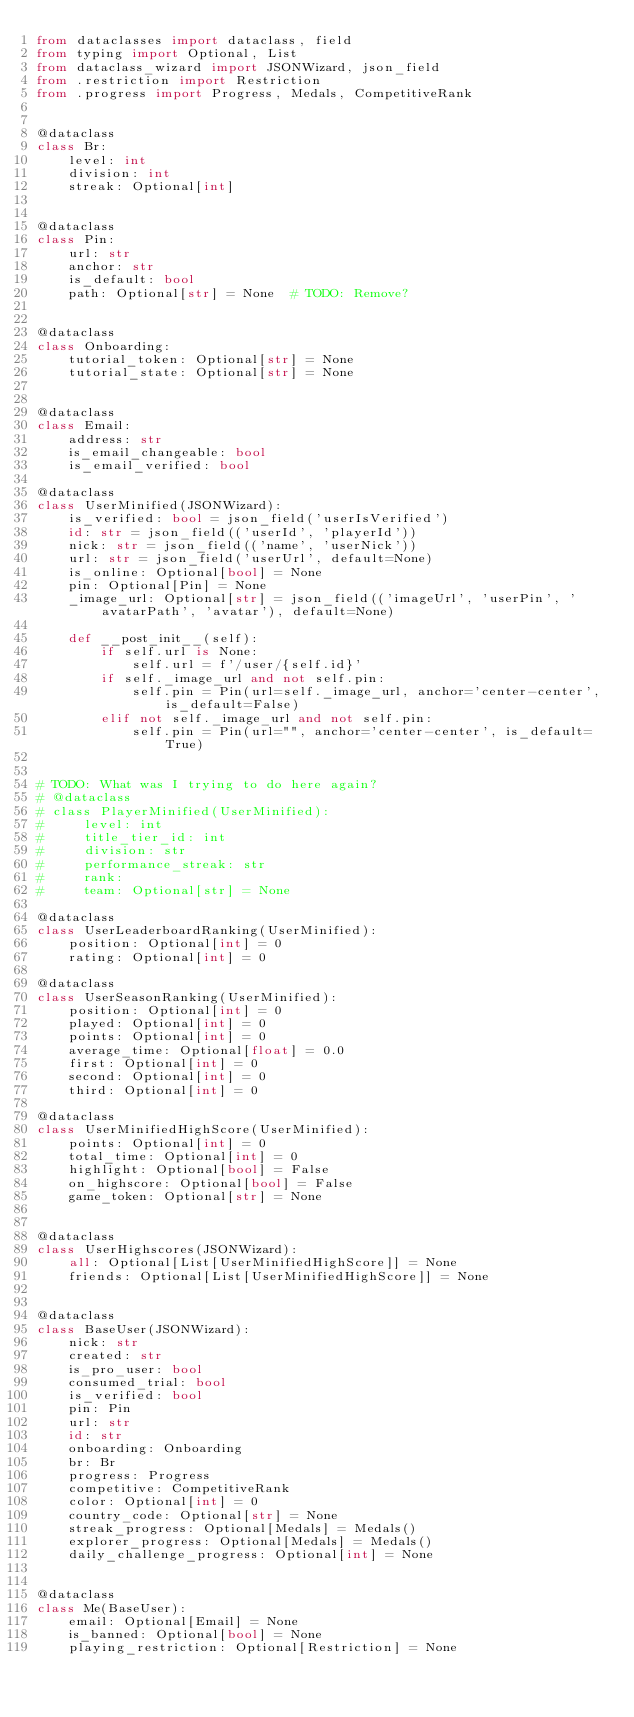<code> <loc_0><loc_0><loc_500><loc_500><_Python_>from dataclasses import dataclass, field
from typing import Optional, List
from dataclass_wizard import JSONWizard, json_field
from .restriction import Restriction
from .progress import Progress, Medals, CompetitiveRank


@dataclass
class Br:
    level: int
    division: int
    streak: Optional[int]


@dataclass
class Pin:
    url: str
    anchor: str
    is_default: bool
    path: Optional[str] = None  # TODO: Remove?


@dataclass
class Onboarding:
    tutorial_token: Optional[str] = None
    tutorial_state: Optional[str] = None


@dataclass
class Email:
    address: str
    is_email_changeable: bool
    is_email_verified: bool

@dataclass
class UserMinified(JSONWizard):
    is_verified: bool = json_field('userIsVerified')
    id: str = json_field(('userId', 'playerId'))
    nick: str = json_field(('name', 'userNick'))
    url: str = json_field('userUrl', default=None)
    is_online: Optional[bool] = None
    pin: Optional[Pin] = None
    _image_url: Optional[str] = json_field(('imageUrl', 'userPin', 'avatarPath', 'avatar'), default=None)

    def __post_init__(self):
        if self.url is None:
            self.url = f'/user/{self.id}'
        if self._image_url and not self.pin:
            self.pin = Pin(url=self._image_url, anchor='center-center', is_default=False)
        elif not self._image_url and not self.pin:
            self.pin = Pin(url="", anchor='center-center', is_default=True)


# TODO: What was I trying to do here again?
# @dataclass
# class PlayerMinified(UserMinified):
#     level: int
#     title_tier_id: int
#     division: str
#     performance_streak: str
#     rank:
#     team: Optional[str] = None

@dataclass
class UserLeaderboardRanking(UserMinified):
    position: Optional[int] = 0
    rating: Optional[int] = 0

@dataclass
class UserSeasonRanking(UserMinified):
    position: Optional[int] = 0
    played: Optional[int] = 0
    points: Optional[int] = 0
    average_time: Optional[float] = 0.0
    first: Optional[int] = 0
    second: Optional[int] = 0
    third: Optional[int] = 0

@dataclass
class UserMinifiedHighScore(UserMinified):
    points: Optional[int] = 0
    total_time: Optional[int] = 0
    highlight: Optional[bool] = False
    on_highscore: Optional[bool] = False
    game_token: Optional[str] = None


@dataclass
class UserHighscores(JSONWizard):
    all: Optional[List[UserMinifiedHighScore]] = None
    friends: Optional[List[UserMinifiedHighScore]] = None


@dataclass
class BaseUser(JSONWizard):
    nick: str
    created: str
    is_pro_user: bool
    consumed_trial: bool
    is_verified: bool
    pin: Pin
    url: str
    id: str
    onboarding: Onboarding
    br: Br
    progress: Progress
    competitive: CompetitiveRank
    color: Optional[int] = 0
    country_code: Optional[str] = None
    streak_progress: Optional[Medals] = Medals()
    explorer_progress: Optional[Medals] = Medals()
    daily_challenge_progress: Optional[int] = None


@dataclass
class Me(BaseUser):
    email: Optional[Email] = None
    is_banned: Optional[bool] = None
    playing_restriction: Optional[Restriction] = None
</code> 